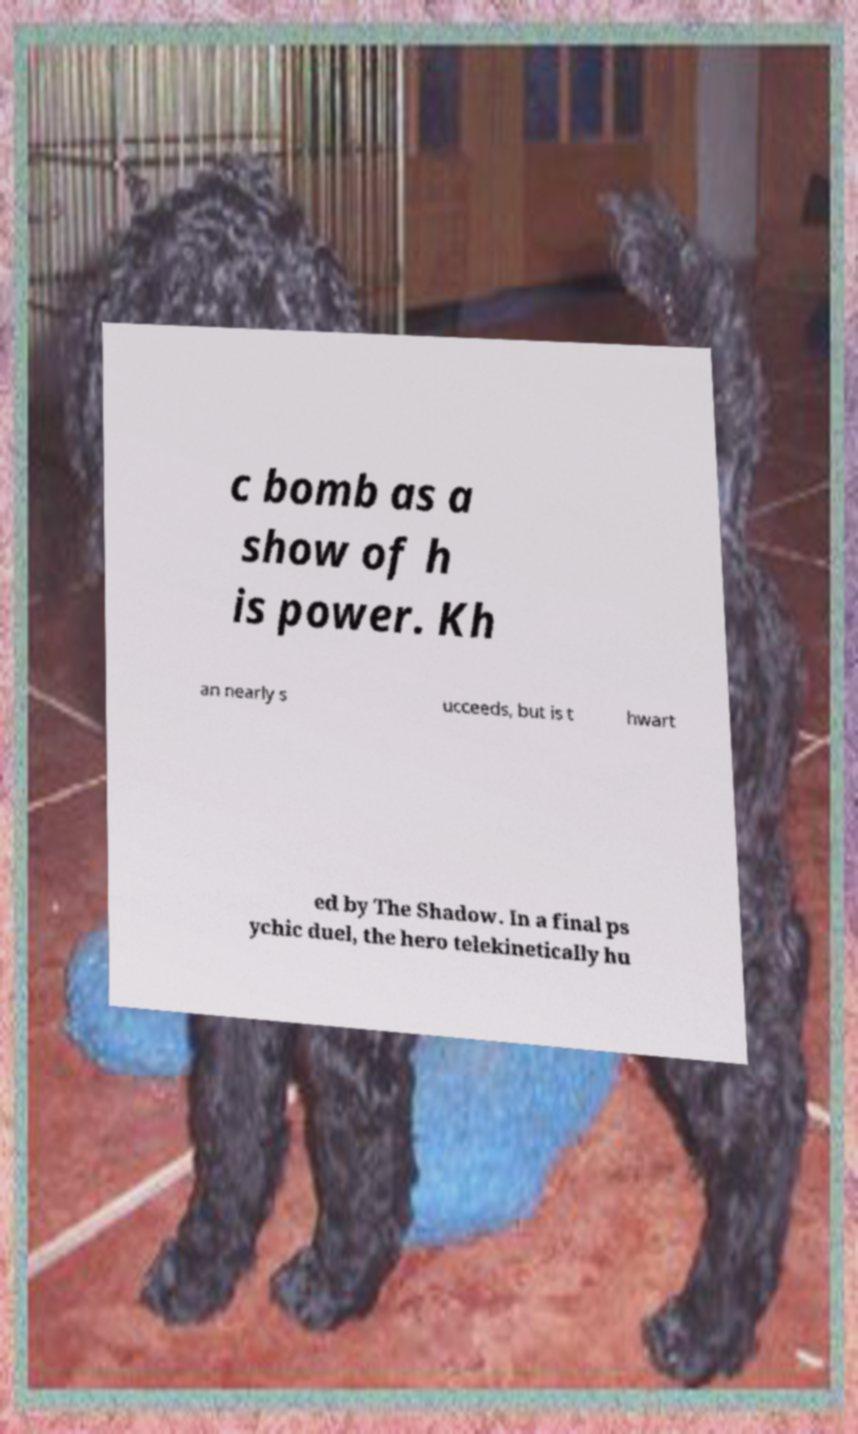There's text embedded in this image that I need extracted. Can you transcribe it verbatim? c bomb as a show of h is power. Kh an nearly s ucceeds, but is t hwart ed by The Shadow. In a final ps ychic duel, the hero telekinetically hu 